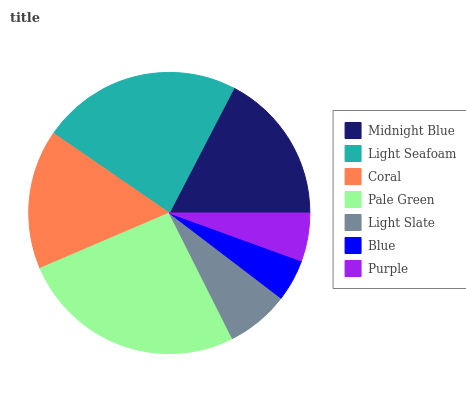Is Blue the minimum?
Answer yes or no. Yes. Is Pale Green the maximum?
Answer yes or no. Yes. Is Light Seafoam the minimum?
Answer yes or no. No. Is Light Seafoam the maximum?
Answer yes or no. No. Is Light Seafoam greater than Midnight Blue?
Answer yes or no. Yes. Is Midnight Blue less than Light Seafoam?
Answer yes or no. Yes. Is Midnight Blue greater than Light Seafoam?
Answer yes or no. No. Is Light Seafoam less than Midnight Blue?
Answer yes or no. No. Is Coral the high median?
Answer yes or no. Yes. Is Coral the low median?
Answer yes or no. Yes. Is Light Slate the high median?
Answer yes or no. No. Is Purple the low median?
Answer yes or no. No. 